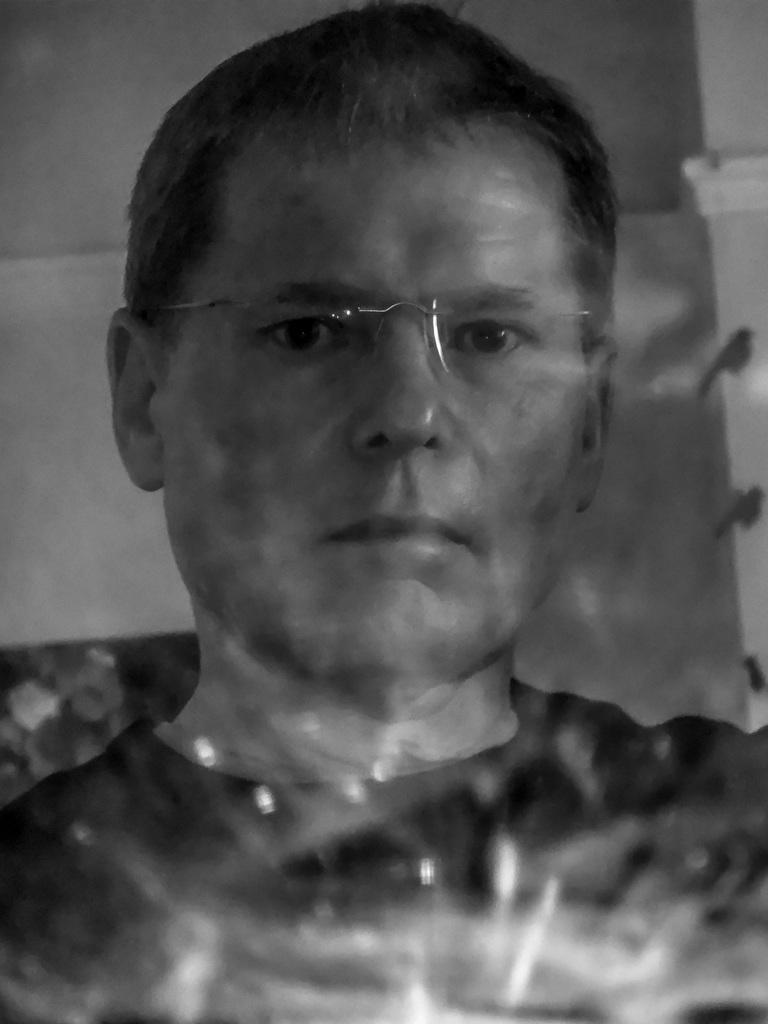What is the main subject of the image? There is a person in the image. Can you describe the person's appearance? The person is wearing glasses. What type of cable is connected to the person's glasses in the image? There is no cable connected to the person's glasses in the image. 